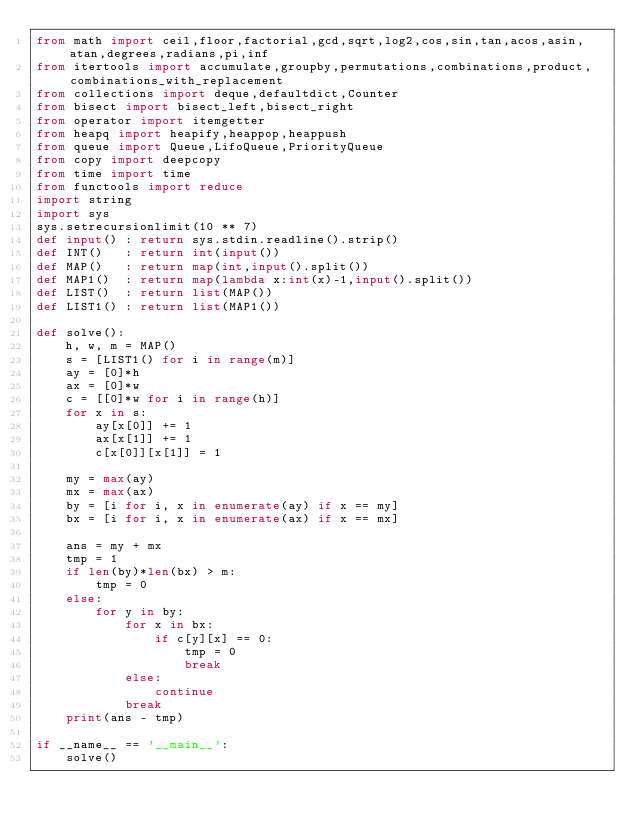<code> <loc_0><loc_0><loc_500><loc_500><_Python_>from math import ceil,floor,factorial,gcd,sqrt,log2,cos,sin,tan,acos,asin,atan,degrees,radians,pi,inf
from itertools import accumulate,groupby,permutations,combinations,product,combinations_with_replacement
from collections import deque,defaultdict,Counter
from bisect import bisect_left,bisect_right
from operator import itemgetter
from heapq import heapify,heappop,heappush
from queue import Queue,LifoQueue,PriorityQueue
from copy import deepcopy
from time import time
from functools import reduce
import string
import sys
sys.setrecursionlimit(10 ** 7)
def input() : return sys.stdin.readline().strip()
def INT()   : return int(input())
def MAP()   : return map(int,input().split())
def MAP1()  : return map(lambda x:int(x)-1,input().split())
def LIST()  : return list(MAP())
def LIST1() : return list(MAP1())

def solve():
    h, w, m = MAP()
    s = [LIST1() for i in range(m)]
    ay = [0]*h
    ax = [0]*w
    c = [[0]*w for i in range(h)]
    for x in s:
        ay[x[0]] += 1
        ax[x[1]] += 1
        c[x[0]][x[1]] = 1

    my = max(ay)
    mx = max(ax)
    by = [i for i, x in enumerate(ay) if x == my]
    bx = [i for i, x in enumerate(ax) if x == mx]

    ans = my + mx
    tmp = 1
    if len(by)*len(bx) > m:
        tmp = 0
    else:
        for y in by:
            for x in bx:
                if c[y][x] == 0:
                    tmp = 0
                    break
            else:
                continue
            break
    print(ans - tmp)

if __name__ == '__main__':
    solve()
</code> 